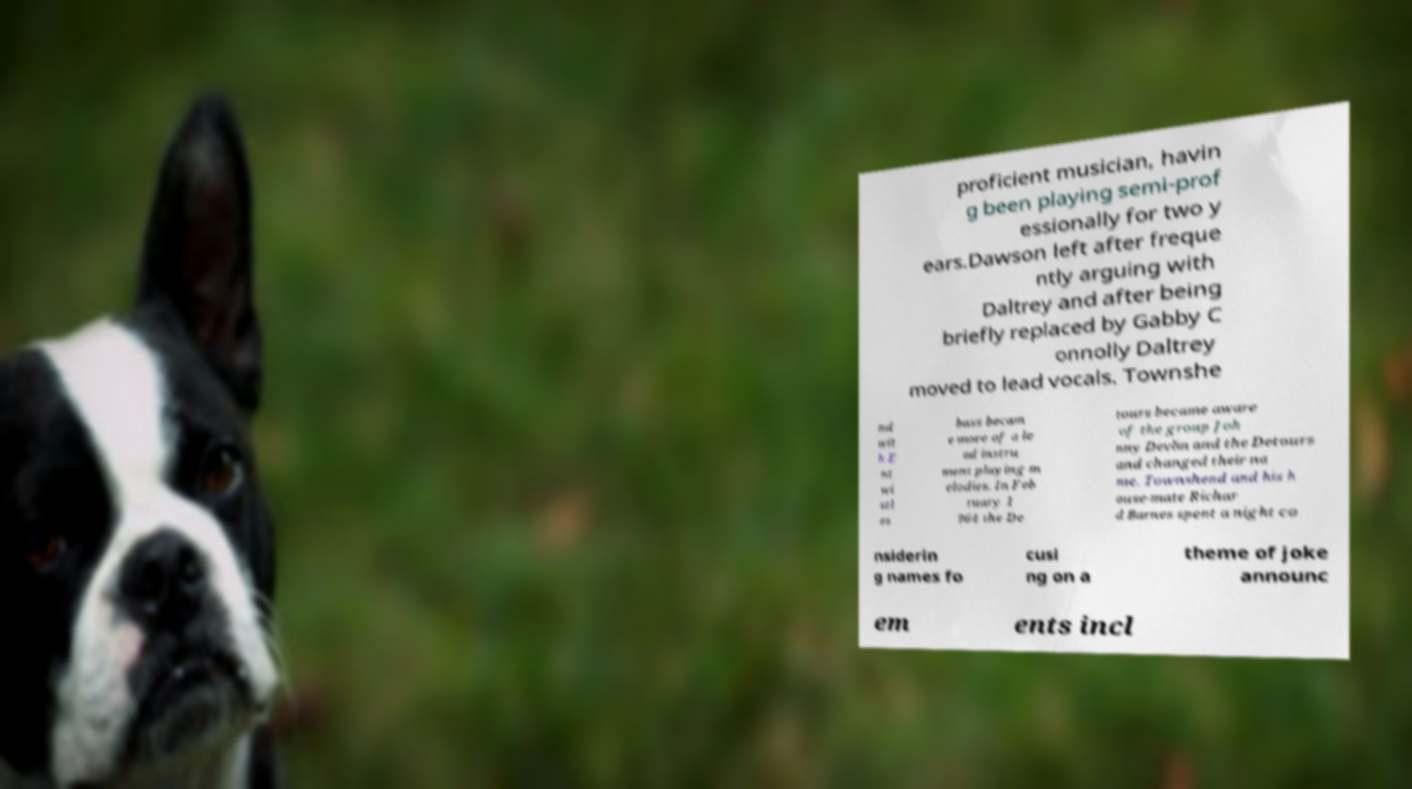Can you read and provide the text displayed in the image?This photo seems to have some interesting text. Can you extract and type it out for me? proficient musician, havin g been playing semi-prof essionally for two y ears.Dawson left after freque ntly arguing with Daltrey and after being briefly replaced by Gabby C onnolly Daltrey moved to lead vocals. Townshe nd wit h E nt wi stl es bass becam e more of a le ad instru ment playing m elodies. In Feb ruary 1 964 the De tours became aware of the group Joh nny Devlin and the Detours and changed their na me. Townshend and his h ouse-mate Richar d Barnes spent a night co nsiderin g names fo cusi ng on a theme of joke announc em ents incl 